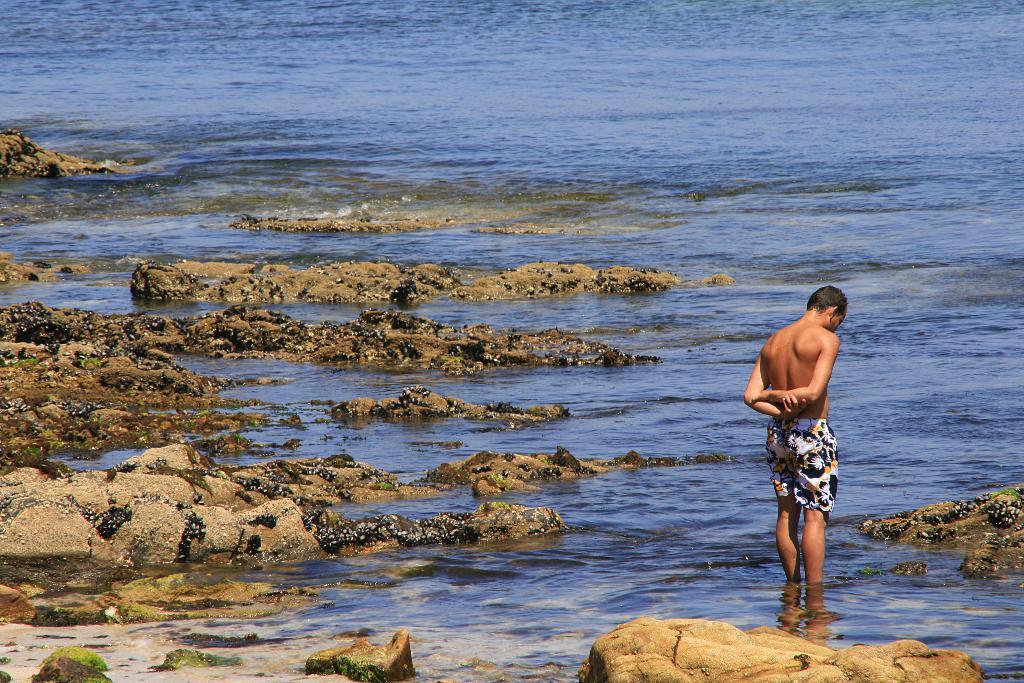How would you summarize this image in a sentence or two? In this picture we can see a man standing, at the bottom there is water, we can see soil and rocks at the bottom. 